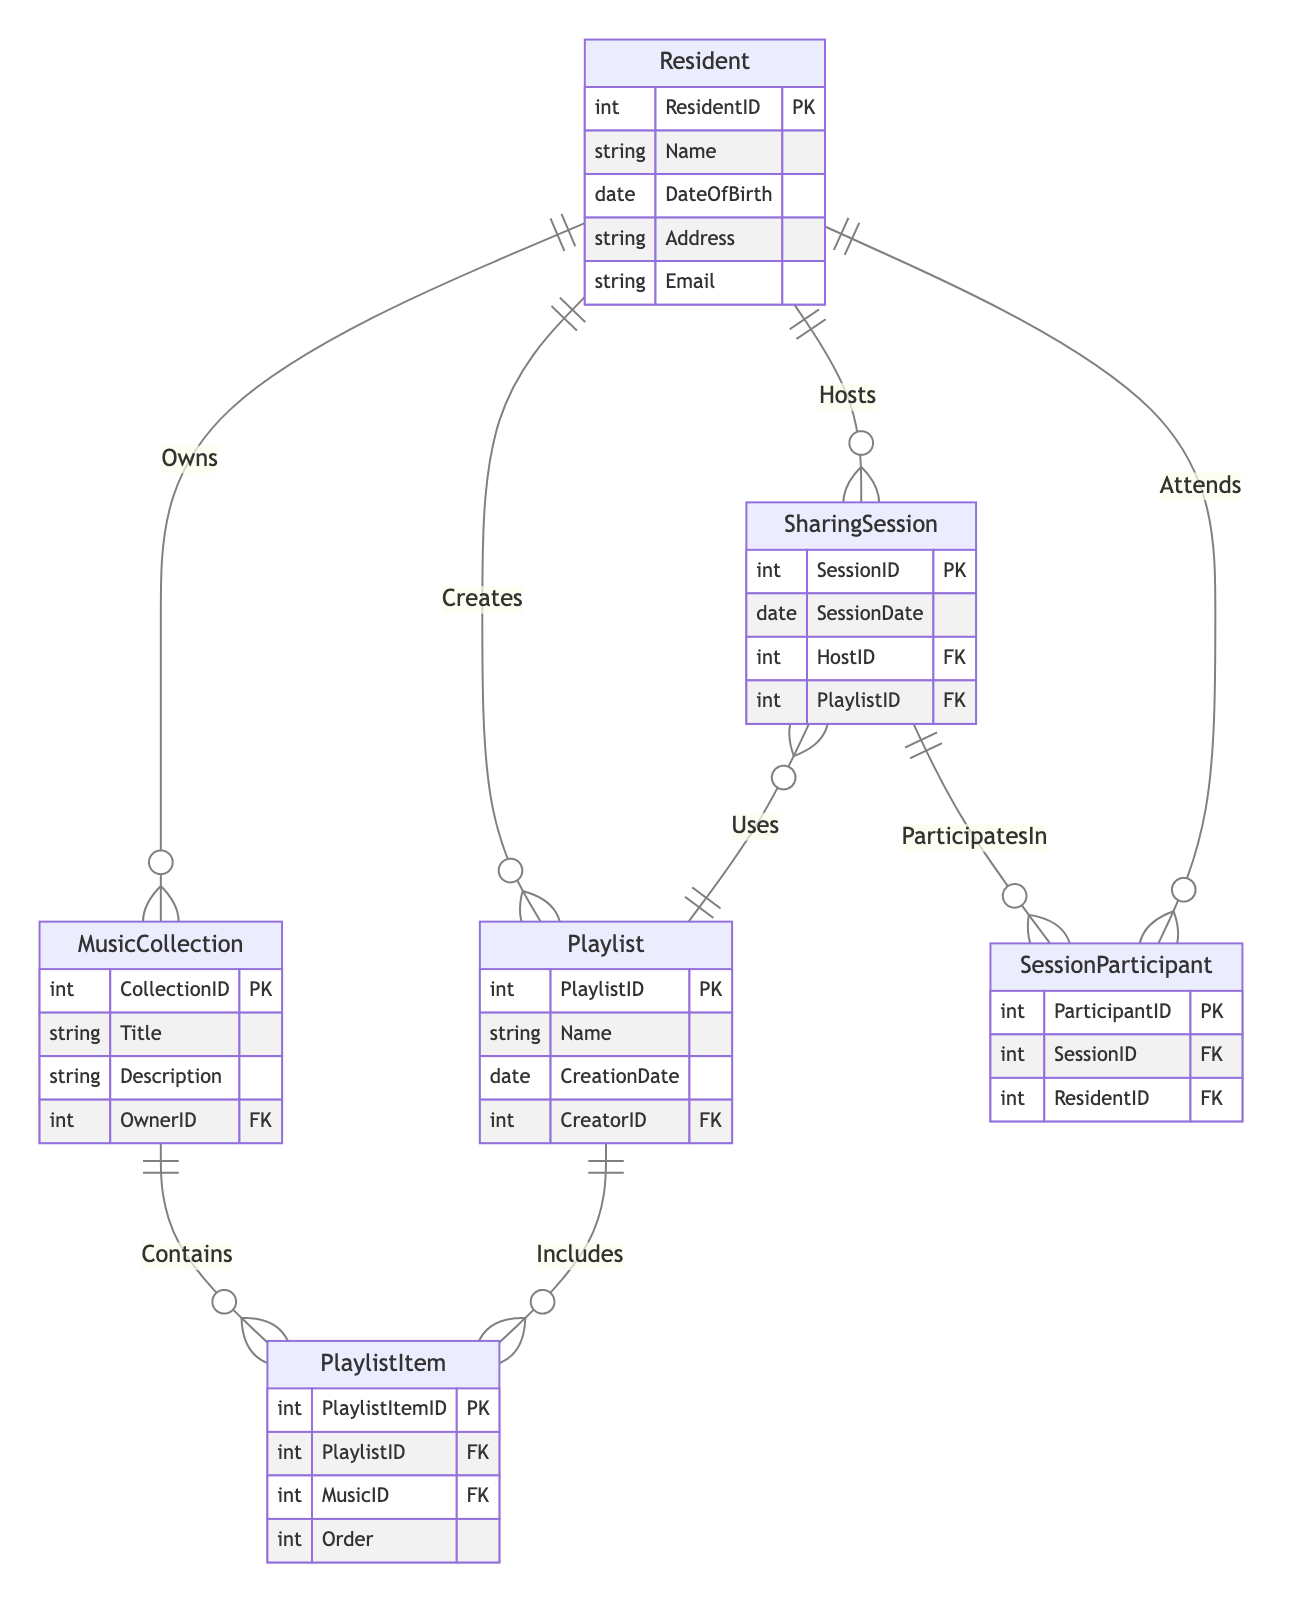What is the primary key for the Resident entity? The primary key for the Resident entity is indicated as "PK" next to "ResidentID." This means that "ResidentID" uniquely identifies each resident in the database.
Answer: ResidentID How many attributes does the MusicCollection entity have? The MusicCollection entity has four attributes: "CollectionID," "Title," "Description," and "OwnerID." Counting these indicates that there are four attributes total.
Answer: 4 What relationship type exists between Resident and Playlist? The relationship type between Resident and Playlist is labeled as "1 to many." This indicates that one resident can create multiple playlists.
Answer: 1 to many Which entity does the PlaylistItem entity reference? The PlaylistItem entity references both the Playlist and MusicCollection entities through foreign keys, identified by "PlaylistID" and "MusicID" respectively.
Answer: Playlist and MusicCollection How many sessions can a single Resident host? A single resident can host many sharing sessions, as indicated by the "1 to many" relationship from Resident to SharingSession, meaning one resident could host multiple sessions.
Answer: Many How does a Resident participate in a SharingSession? A resident participates in a SharingSession through the SessionParticipant entity, which has the "ResidentID" foreign key linking to the Resident entity, indicating their participation in a specific session.
Answer: SessionParticipant What type of relationship does Playlist have with PlaylistItem? The type of relationship between Playlist and PlaylistItem is "1 to many," indicating that one playlist can include multiple items.
Answer: 1 to many What does the SharingSession entity use to reference Playlists? The SharingSession entity references Playlists using the foreign key "PlaylistID," indicating which specific playlist is being used for that sharing session.
Answer: PlaylistID How are residents linked to music collections? Residents are linked to music collections through the "Owns" relationship, which indicates that each resident can own multiple music collections, as shown by the "1 to many" relationship type.
Answer: Owns 